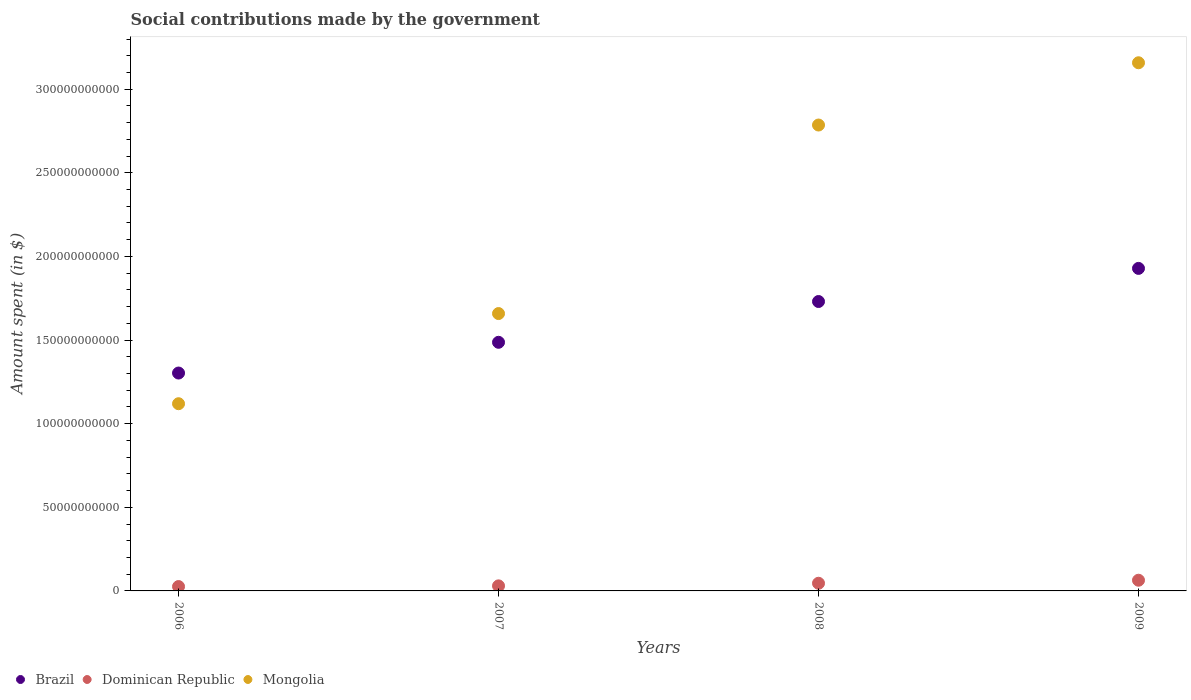How many different coloured dotlines are there?
Your response must be concise. 3. Is the number of dotlines equal to the number of legend labels?
Offer a very short reply. Yes. What is the amount spent on social contributions in Mongolia in 2007?
Provide a succinct answer. 1.66e+11. Across all years, what is the maximum amount spent on social contributions in Mongolia?
Your answer should be very brief. 3.16e+11. Across all years, what is the minimum amount spent on social contributions in Brazil?
Give a very brief answer. 1.30e+11. In which year was the amount spent on social contributions in Dominican Republic maximum?
Keep it short and to the point. 2009. In which year was the amount spent on social contributions in Brazil minimum?
Make the answer very short. 2006. What is the total amount spent on social contributions in Brazil in the graph?
Provide a short and direct response. 6.45e+11. What is the difference between the amount spent on social contributions in Brazil in 2007 and that in 2009?
Offer a very short reply. -4.42e+1. What is the difference between the amount spent on social contributions in Mongolia in 2007 and the amount spent on social contributions in Brazil in 2009?
Offer a very short reply. -2.70e+1. What is the average amount spent on social contributions in Dominican Republic per year?
Your answer should be compact. 4.15e+09. In the year 2007, what is the difference between the amount spent on social contributions in Brazil and amount spent on social contributions in Mongolia?
Offer a very short reply. -1.72e+1. What is the ratio of the amount spent on social contributions in Mongolia in 2006 to that in 2009?
Your answer should be very brief. 0.35. Is the amount spent on social contributions in Dominican Republic in 2008 less than that in 2009?
Your response must be concise. Yes. Is the difference between the amount spent on social contributions in Brazil in 2007 and 2008 greater than the difference between the amount spent on social contributions in Mongolia in 2007 and 2008?
Give a very brief answer. Yes. What is the difference between the highest and the second highest amount spent on social contributions in Dominican Republic?
Ensure brevity in your answer.  1.82e+09. What is the difference between the highest and the lowest amount spent on social contributions in Mongolia?
Ensure brevity in your answer.  2.04e+11. Is it the case that in every year, the sum of the amount spent on social contributions in Mongolia and amount spent on social contributions in Brazil  is greater than the amount spent on social contributions in Dominican Republic?
Your answer should be very brief. Yes. Is the amount spent on social contributions in Mongolia strictly greater than the amount spent on social contributions in Dominican Republic over the years?
Ensure brevity in your answer.  Yes. How many years are there in the graph?
Offer a very short reply. 4. Does the graph contain any zero values?
Your response must be concise. No. Does the graph contain grids?
Ensure brevity in your answer.  No. How many legend labels are there?
Your answer should be very brief. 3. What is the title of the graph?
Your answer should be very brief. Social contributions made by the government. Does "Mauritania" appear as one of the legend labels in the graph?
Your answer should be very brief. No. What is the label or title of the X-axis?
Your answer should be very brief. Years. What is the label or title of the Y-axis?
Provide a short and direct response. Amount spent (in $). What is the Amount spent (in $) of Brazil in 2006?
Provide a short and direct response. 1.30e+11. What is the Amount spent (in $) of Dominican Republic in 2006?
Your answer should be compact. 2.61e+09. What is the Amount spent (in $) of Mongolia in 2006?
Ensure brevity in your answer.  1.12e+11. What is the Amount spent (in $) in Brazil in 2007?
Your response must be concise. 1.49e+11. What is the Amount spent (in $) of Dominican Republic in 2007?
Your answer should be compact. 3.02e+09. What is the Amount spent (in $) in Mongolia in 2007?
Your answer should be compact. 1.66e+11. What is the Amount spent (in $) in Brazil in 2008?
Make the answer very short. 1.73e+11. What is the Amount spent (in $) in Dominican Republic in 2008?
Your response must be concise. 4.58e+09. What is the Amount spent (in $) of Mongolia in 2008?
Make the answer very short. 2.79e+11. What is the Amount spent (in $) in Brazil in 2009?
Your response must be concise. 1.93e+11. What is the Amount spent (in $) of Dominican Republic in 2009?
Offer a very short reply. 6.40e+09. What is the Amount spent (in $) in Mongolia in 2009?
Offer a very short reply. 3.16e+11. Across all years, what is the maximum Amount spent (in $) in Brazil?
Provide a succinct answer. 1.93e+11. Across all years, what is the maximum Amount spent (in $) in Dominican Republic?
Keep it short and to the point. 6.40e+09. Across all years, what is the maximum Amount spent (in $) in Mongolia?
Offer a terse response. 3.16e+11. Across all years, what is the minimum Amount spent (in $) of Brazil?
Offer a very short reply. 1.30e+11. Across all years, what is the minimum Amount spent (in $) of Dominican Republic?
Ensure brevity in your answer.  2.61e+09. Across all years, what is the minimum Amount spent (in $) of Mongolia?
Give a very brief answer. 1.12e+11. What is the total Amount spent (in $) in Brazil in the graph?
Make the answer very short. 6.45e+11. What is the total Amount spent (in $) in Dominican Republic in the graph?
Give a very brief answer. 1.66e+1. What is the total Amount spent (in $) of Mongolia in the graph?
Give a very brief answer. 8.72e+11. What is the difference between the Amount spent (in $) in Brazil in 2006 and that in 2007?
Provide a short and direct response. -1.84e+1. What is the difference between the Amount spent (in $) of Dominican Republic in 2006 and that in 2007?
Offer a terse response. -4.13e+08. What is the difference between the Amount spent (in $) of Mongolia in 2006 and that in 2007?
Give a very brief answer. -5.39e+1. What is the difference between the Amount spent (in $) in Brazil in 2006 and that in 2008?
Provide a succinct answer. -4.28e+1. What is the difference between the Amount spent (in $) in Dominican Republic in 2006 and that in 2008?
Offer a terse response. -1.97e+09. What is the difference between the Amount spent (in $) in Mongolia in 2006 and that in 2008?
Offer a very short reply. -1.67e+11. What is the difference between the Amount spent (in $) of Brazil in 2006 and that in 2009?
Keep it short and to the point. -6.26e+1. What is the difference between the Amount spent (in $) of Dominican Republic in 2006 and that in 2009?
Make the answer very short. -3.79e+09. What is the difference between the Amount spent (in $) in Mongolia in 2006 and that in 2009?
Offer a very short reply. -2.04e+11. What is the difference between the Amount spent (in $) in Brazil in 2007 and that in 2008?
Ensure brevity in your answer.  -2.44e+1. What is the difference between the Amount spent (in $) in Dominican Republic in 2007 and that in 2008?
Offer a very short reply. -1.56e+09. What is the difference between the Amount spent (in $) in Mongolia in 2007 and that in 2008?
Your answer should be very brief. -1.13e+11. What is the difference between the Amount spent (in $) of Brazil in 2007 and that in 2009?
Give a very brief answer. -4.42e+1. What is the difference between the Amount spent (in $) in Dominican Republic in 2007 and that in 2009?
Your response must be concise. -3.37e+09. What is the difference between the Amount spent (in $) in Mongolia in 2007 and that in 2009?
Your answer should be very brief. -1.50e+11. What is the difference between the Amount spent (in $) of Brazil in 2008 and that in 2009?
Provide a short and direct response. -1.98e+1. What is the difference between the Amount spent (in $) of Dominican Republic in 2008 and that in 2009?
Your answer should be very brief. -1.82e+09. What is the difference between the Amount spent (in $) of Mongolia in 2008 and that in 2009?
Offer a very short reply. -3.72e+1. What is the difference between the Amount spent (in $) in Brazil in 2006 and the Amount spent (in $) in Dominican Republic in 2007?
Your answer should be very brief. 1.27e+11. What is the difference between the Amount spent (in $) in Brazil in 2006 and the Amount spent (in $) in Mongolia in 2007?
Keep it short and to the point. -3.56e+1. What is the difference between the Amount spent (in $) of Dominican Republic in 2006 and the Amount spent (in $) of Mongolia in 2007?
Ensure brevity in your answer.  -1.63e+11. What is the difference between the Amount spent (in $) in Brazil in 2006 and the Amount spent (in $) in Dominican Republic in 2008?
Offer a very short reply. 1.26e+11. What is the difference between the Amount spent (in $) of Brazil in 2006 and the Amount spent (in $) of Mongolia in 2008?
Make the answer very short. -1.48e+11. What is the difference between the Amount spent (in $) of Dominican Republic in 2006 and the Amount spent (in $) of Mongolia in 2008?
Your response must be concise. -2.76e+11. What is the difference between the Amount spent (in $) in Brazil in 2006 and the Amount spent (in $) in Dominican Republic in 2009?
Ensure brevity in your answer.  1.24e+11. What is the difference between the Amount spent (in $) of Brazil in 2006 and the Amount spent (in $) of Mongolia in 2009?
Ensure brevity in your answer.  -1.86e+11. What is the difference between the Amount spent (in $) in Dominican Republic in 2006 and the Amount spent (in $) in Mongolia in 2009?
Offer a terse response. -3.13e+11. What is the difference between the Amount spent (in $) in Brazil in 2007 and the Amount spent (in $) in Dominican Republic in 2008?
Provide a succinct answer. 1.44e+11. What is the difference between the Amount spent (in $) of Brazil in 2007 and the Amount spent (in $) of Mongolia in 2008?
Ensure brevity in your answer.  -1.30e+11. What is the difference between the Amount spent (in $) in Dominican Republic in 2007 and the Amount spent (in $) in Mongolia in 2008?
Offer a very short reply. -2.76e+11. What is the difference between the Amount spent (in $) of Brazil in 2007 and the Amount spent (in $) of Dominican Republic in 2009?
Provide a short and direct response. 1.42e+11. What is the difference between the Amount spent (in $) of Brazil in 2007 and the Amount spent (in $) of Mongolia in 2009?
Your answer should be compact. -1.67e+11. What is the difference between the Amount spent (in $) in Dominican Republic in 2007 and the Amount spent (in $) in Mongolia in 2009?
Ensure brevity in your answer.  -3.13e+11. What is the difference between the Amount spent (in $) of Brazil in 2008 and the Amount spent (in $) of Dominican Republic in 2009?
Keep it short and to the point. 1.67e+11. What is the difference between the Amount spent (in $) of Brazil in 2008 and the Amount spent (in $) of Mongolia in 2009?
Provide a short and direct response. -1.43e+11. What is the difference between the Amount spent (in $) of Dominican Republic in 2008 and the Amount spent (in $) of Mongolia in 2009?
Keep it short and to the point. -3.11e+11. What is the average Amount spent (in $) in Brazil per year?
Your answer should be compact. 1.61e+11. What is the average Amount spent (in $) of Dominican Republic per year?
Your response must be concise. 4.15e+09. What is the average Amount spent (in $) of Mongolia per year?
Offer a terse response. 2.18e+11. In the year 2006, what is the difference between the Amount spent (in $) of Brazil and Amount spent (in $) of Dominican Republic?
Ensure brevity in your answer.  1.28e+11. In the year 2006, what is the difference between the Amount spent (in $) in Brazil and Amount spent (in $) in Mongolia?
Offer a terse response. 1.83e+1. In the year 2006, what is the difference between the Amount spent (in $) in Dominican Republic and Amount spent (in $) in Mongolia?
Your response must be concise. -1.09e+11. In the year 2007, what is the difference between the Amount spent (in $) in Brazil and Amount spent (in $) in Dominican Republic?
Your answer should be very brief. 1.46e+11. In the year 2007, what is the difference between the Amount spent (in $) of Brazil and Amount spent (in $) of Mongolia?
Offer a terse response. -1.72e+1. In the year 2007, what is the difference between the Amount spent (in $) in Dominican Republic and Amount spent (in $) in Mongolia?
Provide a succinct answer. -1.63e+11. In the year 2008, what is the difference between the Amount spent (in $) of Brazil and Amount spent (in $) of Dominican Republic?
Ensure brevity in your answer.  1.68e+11. In the year 2008, what is the difference between the Amount spent (in $) of Brazil and Amount spent (in $) of Mongolia?
Offer a very short reply. -1.06e+11. In the year 2008, what is the difference between the Amount spent (in $) of Dominican Republic and Amount spent (in $) of Mongolia?
Make the answer very short. -2.74e+11. In the year 2009, what is the difference between the Amount spent (in $) in Brazil and Amount spent (in $) in Dominican Republic?
Offer a terse response. 1.86e+11. In the year 2009, what is the difference between the Amount spent (in $) in Brazil and Amount spent (in $) in Mongolia?
Ensure brevity in your answer.  -1.23e+11. In the year 2009, what is the difference between the Amount spent (in $) in Dominican Republic and Amount spent (in $) in Mongolia?
Your answer should be very brief. -3.09e+11. What is the ratio of the Amount spent (in $) in Brazil in 2006 to that in 2007?
Your response must be concise. 0.88. What is the ratio of the Amount spent (in $) of Dominican Republic in 2006 to that in 2007?
Make the answer very short. 0.86. What is the ratio of the Amount spent (in $) of Mongolia in 2006 to that in 2007?
Offer a very short reply. 0.67. What is the ratio of the Amount spent (in $) in Brazil in 2006 to that in 2008?
Your response must be concise. 0.75. What is the ratio of the Amount spent (in $) of Dominican Republic in 2006 to that in 2008?
Provide a succinct answer. 0.57. What is the ratio of the Amount spent (in $) in Mongolia in 2006 to that in 2008?
Your answer should be very brief. 0.4. What is the ratio of the Amount spent (in $) in Brazil in 2006 to that in 2009?
Make the answer very short. 0.68. What is the ratio of the Amount spent (in $) in Dominican Republic in 2006 to that in 2009?
Your response must be concise. 0.41. What is the ratio of the Amount spent (in $) in Mongolia in 2006 to that in 2009?
Make the answer very short. 0.35. What is the ratio of the Amount spent (in $) in Brazil in 2007 to that in 2008?
Your answer should be very brief. 0.86. What is the ratio of the Amount spent (in $) of Dominican Republic in 2007 to that in 2008?
Keep it short and to the point. 0.66. What is the ratio of the Amount spent (in $) in Mongolia in 2007 to that in 2008?
Give a very brief answer. 0.6. What is the ratio of the Amount spent (in $) in Brazil in 2007 to that in 2009?
Make the answer very short. 0.77. What is the ratio of the Amount spent (in $) of Dominican Republic in 2007 to that in 2009?
Ensure brevity in your answer.  0.47. What is the ratio of the Amount spent (in $) of Mongolia in 2007 to that in 2009?
Offer a very short reply. 0.53. What is the ratio of the Amount spent (in $) in Brazil in 2008 to that in 2009?
Make the answer very short. 0.9. What is the ratio of the Amount spent (in $) of Dominican Republic in 2008 to that in 2009?
Give a very brief answer. 0.72. What is the ratio of the Amount spent (in $) of Mongolia in 2008 to that in 2009?
Provide a short and direct response. 0.88. What is the difference between the highest and the second highest Amount spent (in $) in Brazil?
Ensure brevity in your answer.  1.98e+1. What is the difference between the highest and the second highest Amount spent (in $) of Dominican Republic?
Make the answer very short. 1.82e+09. What is the difference between the highest and the second highest Amount spent (in $) of Mongolia?
Your response must be concise. 3.72e+1. What is the difference between the highest and the lowest Amount spent (in $) in Brazil?
Offer a very short reply. 6.26e+1. What is the difference between the highest and the lowest Amount spent (in $) in Dominican Republic?
Give a very brief answer. 3.79e+09. What is the difference between the highest and the lowest Amount spent (in $) in Mongolia?
Keep it short and to the point. 2.04e+11. 